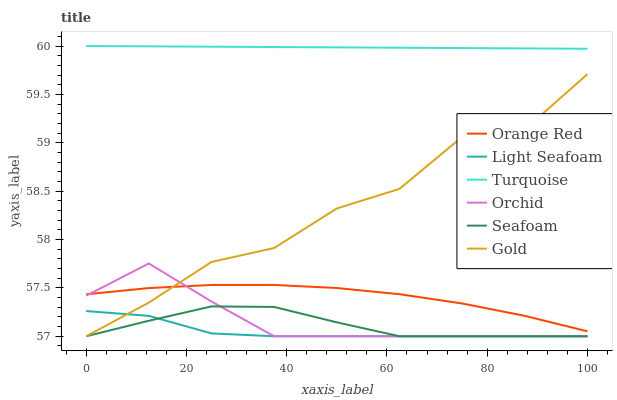Does Light Seafoam have the minimum area under the curve?
Answer yes or no. Yes. Does Turquoise have the maximum area under the curve?
Answer yes or no. Yes. Does Gold have the minimum area under the curve?
Answer yes or no. No. Does Gold have the maximum area under the curve?
Answer yes or no. No. Is Turquoise the smoothest?
Answer yes or no. Yes. Is Gold the roughest?
Answer yes or no. Yes. Is Seafoam the smoothest?
Answer yes or no. No. Is Seafoam the roughest?
Answer yes or no. No. Does Gold have the lowest value?
Answer yes or no. Yes. Does Orange Red have the lowest value?
Answer yes or no. No. Does Turquoise have the highest value?
Answer yes or no. Yes. Does Gold have the highest value?
Answer yes or no. No. Is Seafoam less than Orange Red?
Answer yes or no. Yes. Is Turquoise greater than Light Seafoam?
Answer yes or no. Yes. Does Gold intersect Seafoam?
Answer yes or no. Yes. Is Gold less than Seafoam?
Answer yes or no. No. Is Gold greater than Seafoam?
Answer yes or no. No. Does Seafoam intersect Orange Red?
Answer yes or no. No. 